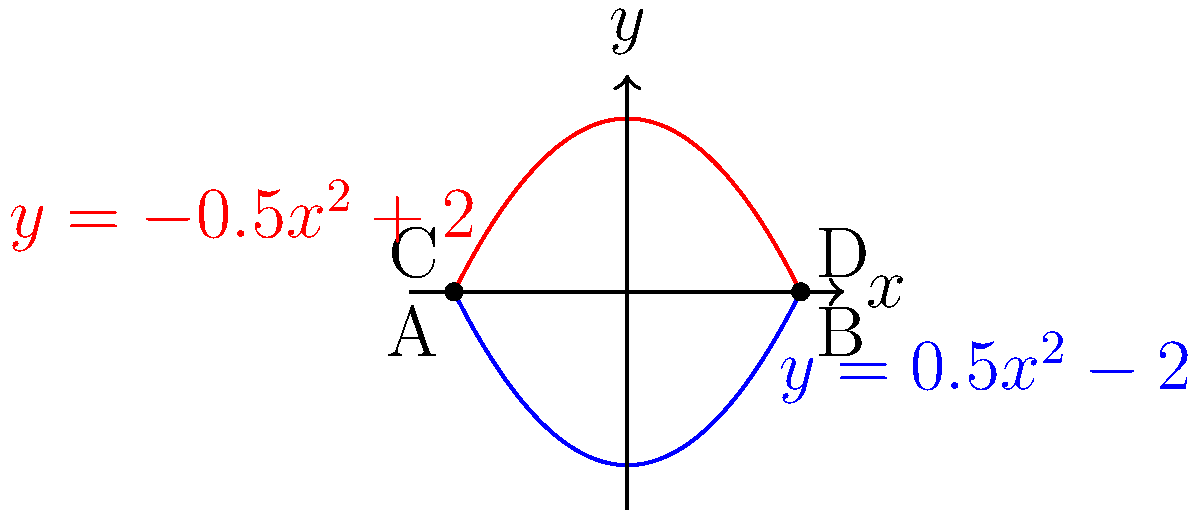As a graphic designer with a knack for funny illustrations, you've decided to create a comical face profile using calculus curves. The face is formed by the area between two parabolas: $y = 0.5x^2 - 2$ (blue curve) and $y = -0.5x^2 + 2$ (red curve) from $x = -2$ to $x = 2$. Calculate the area of this hilarious face to determine just how much mathematical humor you've packed into your design! Let's approach this step-by-step:

1) The area between two curves is given by the formula:
   $$A = \int_{a}^{b} [f(x) - g(x)] dx$$
   where $f(x)$ is the upper function and $g(x)$ is the lower function.

2) In our case:
   $f(x) = -0.5x^2 + 2$ (upper red curve)
   $g(x) = 0.5x^2 - 2$ (lower blue curve)
   $a = -2$ and $b = 2$

3) Substituting into our formula:
   $$A = \int_{-2}^{2} [(-0.5x^2 + 2) - (0.5x^2 - 2)] dx$$

4) Simplify the integrand:
   $$A = \int_{-2}^{2} [-0.5x^2 + 2 - 0.5x^2 + 2] dx = \int_{-2}^{2} [-x^2 + 4] dx$$

5) Integrate:
   $$A = [-\frac{1}{3}x^3 + 4x]_{-2}^{2}$$

6) Evaluate the definite integral:
   $$A = [-\frac{1}{3}(2)^3 + 4(2)] - [-\frac{1}{3}(-2)^3 + 4(-2)]$$
   $$A = [-\frac{8}{3} + 8] - [\frac{8}{3} - 8]$$
   $$A = [\frac{16}{3}] - [-\frac{16}{3}] = \frac{32}{3}$$

7) Therefore, the area of your comical face profile is $\frac{32}{3}$ square units.
Answer: $\frac{32}{3}$ square units 